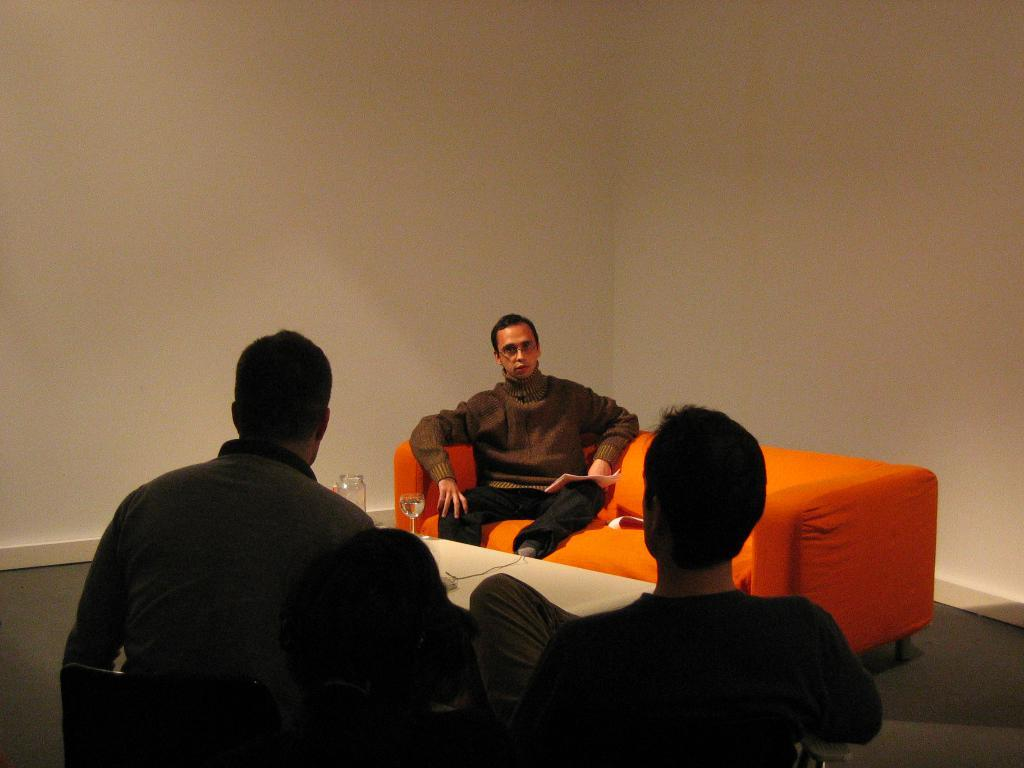What color is the wall in the background of the image? The wall in the background of the image has cream-colored paint. What can be seen beneath the men in the image? The floor is visible in the image. What are the men doing in the image? The men are sitting on sofas in the image. Where are the men sitting in relation to the table? The men are sitting in front of a table. What objects are on the table in the image? There is a jar and a water glass on the table in the image. How many sisters are sitting on the sofas in the image? There is no mention of sisters in the image; only men are present. What is the aftermath of the wave in the image? There is no wave present in the image, so there is no aftermath to discuss. 